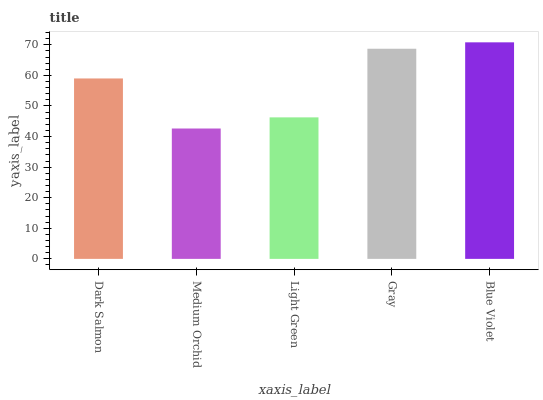Is Light Green the minimum?
Answer yes or no. No. Is Light Green the maximum?
Answer yes or no. No. Is Light Green greater than Medium Orchid?
Answer yes or no. Yes. Is Medium Orchid less than Light Green?
Answer yes or no. Yes. Is Medium Orchid greater than Light Green?
Answer yes or no. No. Is Light Green less than Medium Orchid?
Answer yes or no. No. Is Dark Salmon the high median?
Answer yes or no. Yes. Is Dark Salmon the low median?
Answer yes or no. Yes. Is Blue Violet the high median?
Answer yes or no. No. Is Gray the low median?
Answer yes or no. No. 